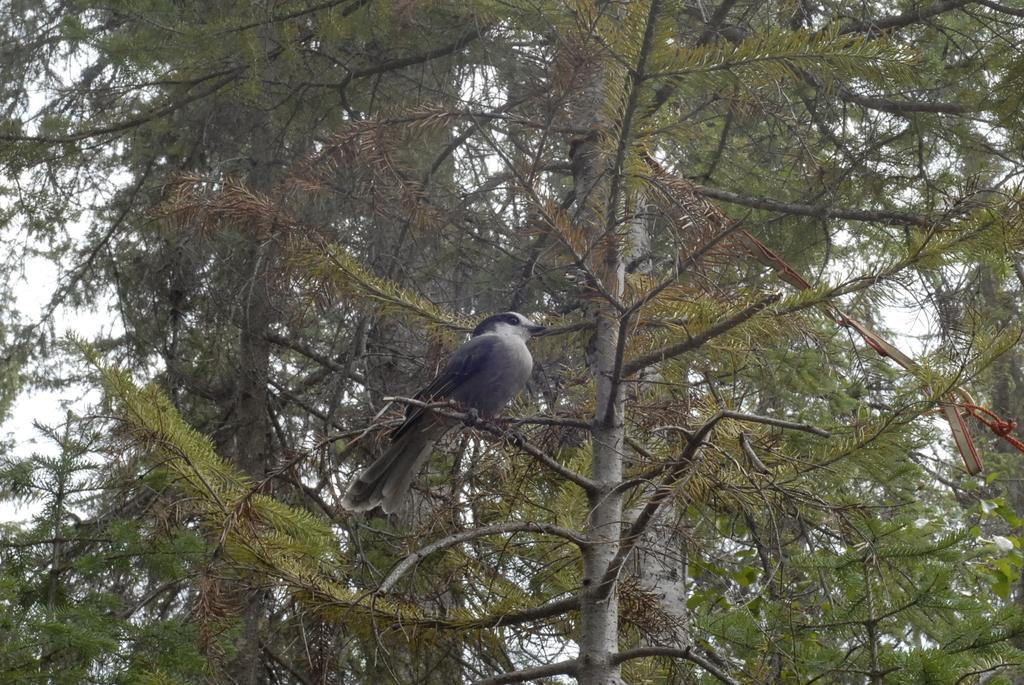What is the main subject of the image? There is a bird in the center of the image. Where is the bird located? The bird is on a stem. What can be seen in the background of the image? There is a tree in the background of the image. What type of thread is being used to hold the bird in place in the image? There is no thread present in the image; the bird is on a stem. How many strings are visible in the image? There are no strings visible in the image. 